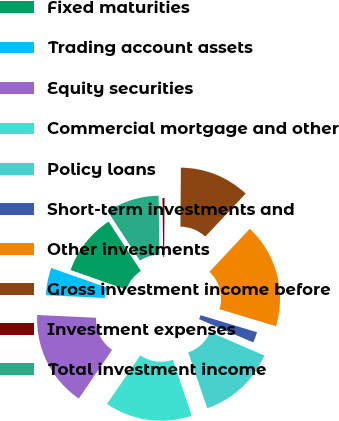<chart> <loc_0><loc_0><loc_500><loc_500><pie_chart><fcel>Fixed maturities<fcel>Trading account assets<fcel>Equity securities<fcel>Commercial mortgage and other<fcel>Policy loans<fcel>Short-term investments and<fcel>Other investments<fcel>Gross investment income before<fcel>Investment expenses<fcel>Total investment income<nl><fcel>10.42%<fcel>4.62%<fcel>16.21%<fcel>14.76%<fcel>13.31%<fcel>1.81%<fcel>17.66%<fcel>11.87%<fcel>0.36%<fcel>8.97%<nl></chart> 